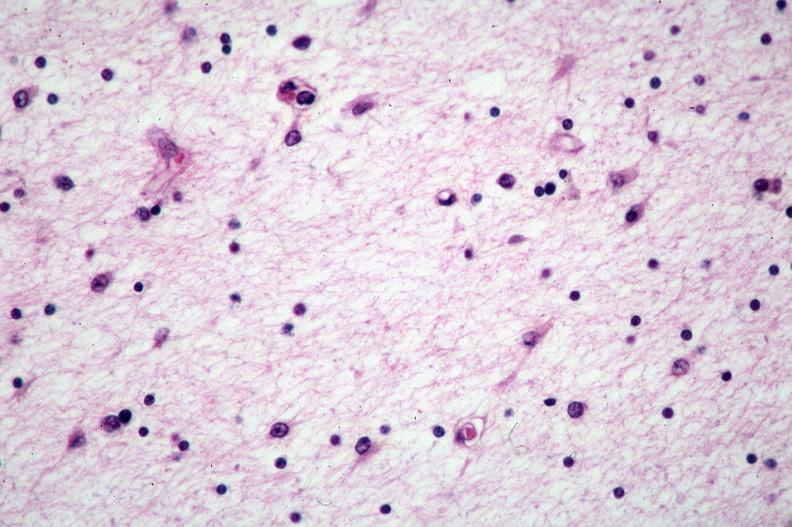s anthracotic pigment present?
Answer the question using a single word or phrase. No 